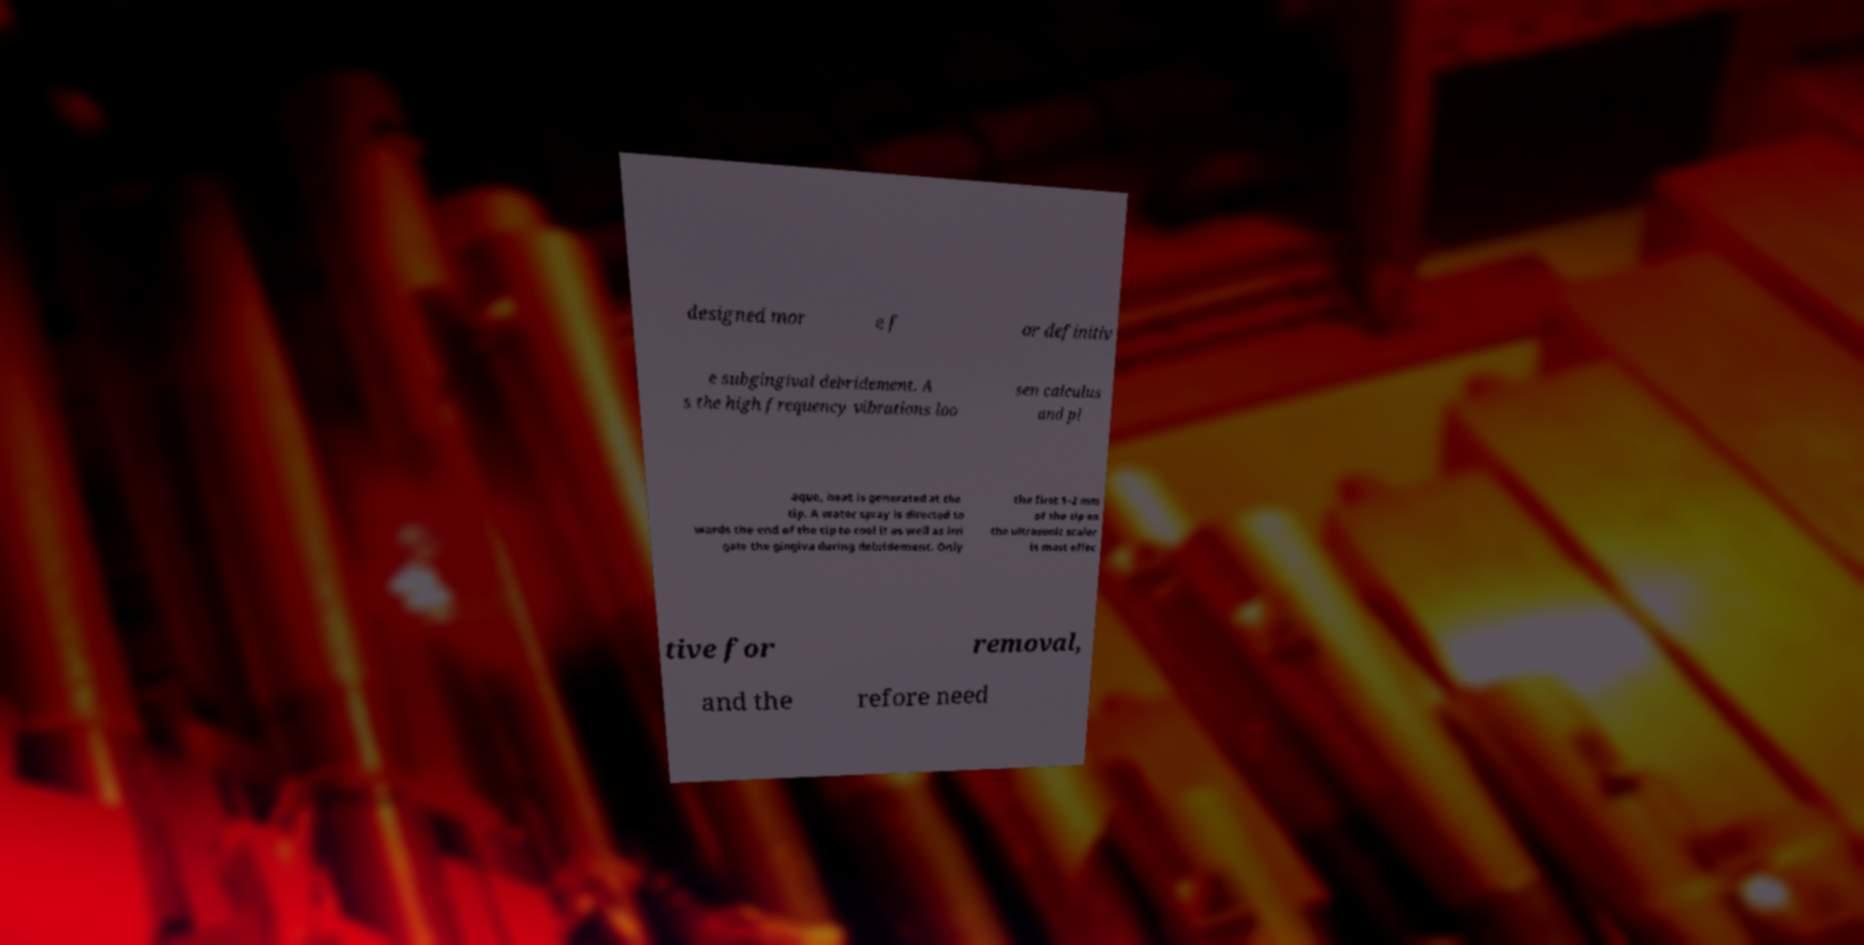There's text embedded in this image that I need extracted. Can you transcribe it verbatim? designed mor e f or definitiv e subgingival debridement. A s the high frequency vibrations loo sen calculus and pl aque, heat is generated at the tip. A water spray is directed to wards the end of the tip to cool it as well as irri gate the gingiva during debridement. Only the first 1–2 mm of the tip on the ultrasonic scaler is most effec tive for removal, and the refore need 